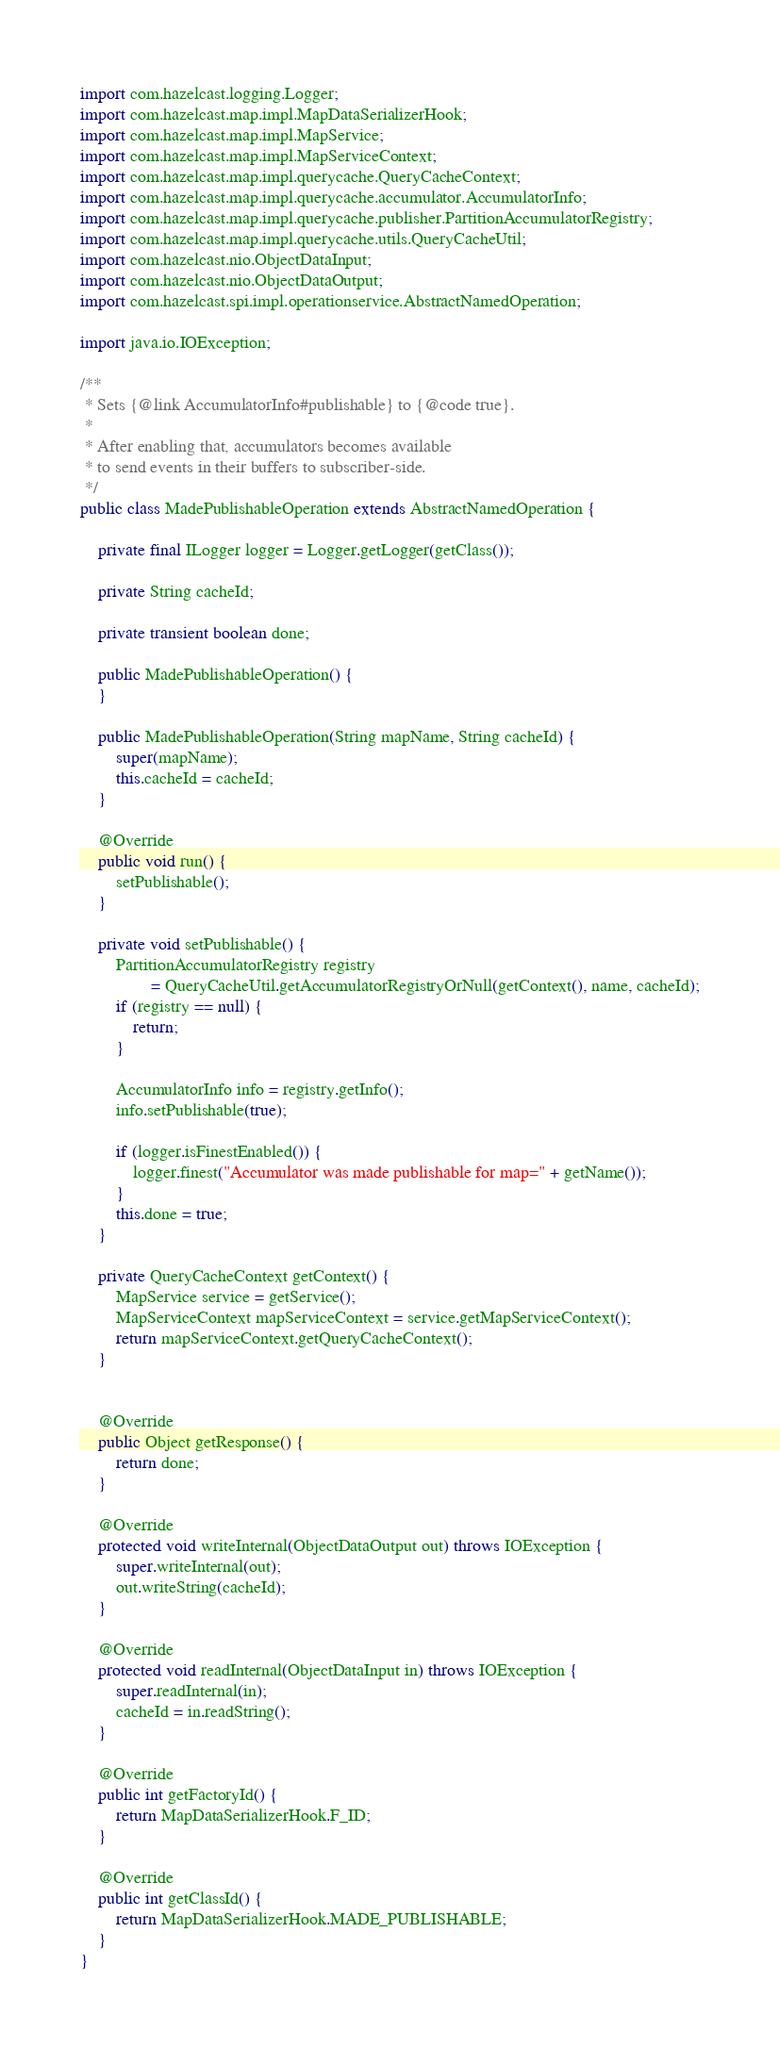Convert code to text. <code><loc_0><loc_0><loc_500><loc_500><_Java_>import com.hazelcast.logging.Logger;
import com.hazelcast.map.impl.MapDataSerializerHook;
import com.hazelcast.map.impl.MapService;
import com.hazelcast.map.impl.MapServiceContext;
import com.hazelcast.map.impl.querycache.QueryCacheContext;
import com.hazelcast.map.impl.querycache.accumulator.AccumulatorInfo;
import com.hazelcast.map.impl.querycache.publisher.PartitionAccumulatorRegistry;
import com.hazelcast.map.impl.querycache.utils.QueryCacheUtil;
import com.hazelcast.nio.ObjectDataInput;
import com.hazelcast.nio.ObjectDataOutput;
import com.hazelcast.spi.impl.operationservice.AbstractNamedOperation;

import java.io.IOException;

/**
 * Sets {@link AccumulatorInfo#publishable} to {@code true}.
 *
 * After enabling that, accumulators becomes available
 * to send events in their buffers to subscriber-side.
 */
public class MadePublishableOperation extends AbstractNamedOperation {

    private final ILogger logger = Logger.getLogger(getClass());

    private String cacheId;

    private transient boolean done;

    public MadePublishableOperation() {
    }

    public MadePublishableOperation(String mapName, String cacheId) {
        super(mapName);
        this.cacheId = cacheId;
    }

    @Override
    public void run() {
        setPublishable();
    }

    private void setPublishable() {
        PartitionAccumulatorRegistry registry
                = QueryCacheUtil.getAccumulatorRegistryOrNull(getContext(), name, cacheId);
        if (registry == null) {
            return;
        }

        AccumulatorInfo info = registry.getInfo();
        info.setPublishable(true);

        if (logger.isFinestEnabled()) {
            logger.finest("Accumulator was made publishable for map=" + getName());
        }
        this.done = true;
    }

    private QueryCacheContext getContext() {
        MapService service = getService();
        MapServiceContext mapServiceContext = service.getMapServiceContext();
        return mapServiceContext.getQueryCacheContext();
    }


    @Override
    public Object getResponse() {
        return done;
    }

    @Override
    protected void writeInternal(ObjectDataOutput out) throws IOException {
        super.writeInternal(out);
        out.writeString(cacheId);
    }

    @Override
    protected void readInternal(ObjectDataInput in) throws IOException {
        super.readInternal(in);
        cacheId = in.readString();
    }

    @Override
    public int getFactoryId() {
        return MapDataSerializerHook.F_ID;
    }

    @Override
    public int getClassId() {
        return MapDataSerializerHook.MADE_PUBLISHABLE;
    }
}
</code> 